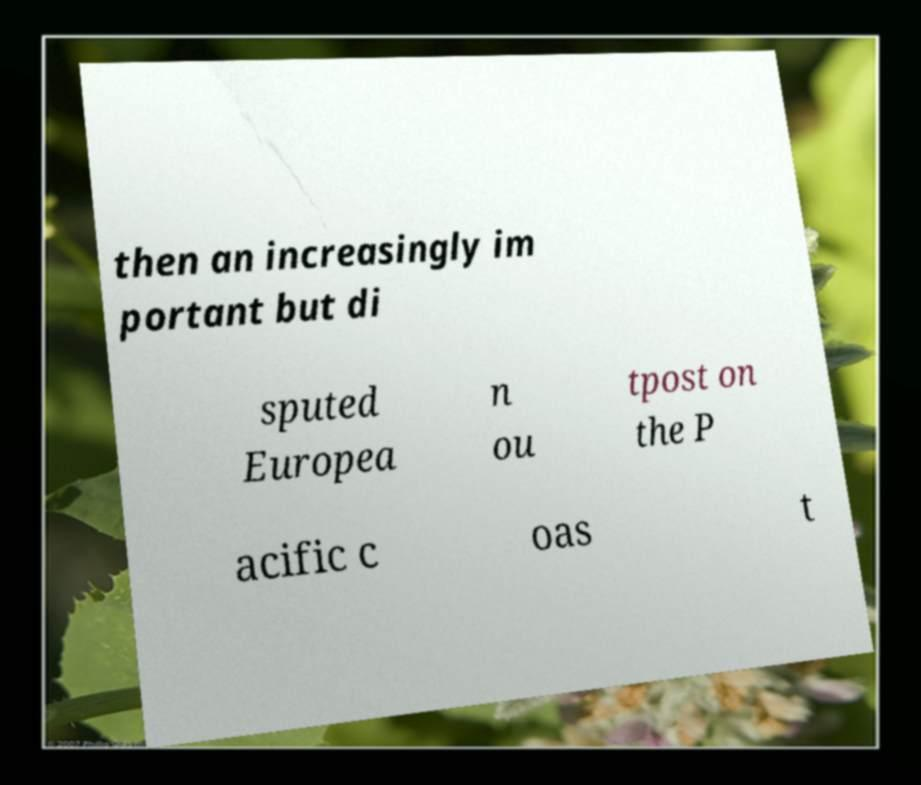Can you accurately transcribe the text from the provided image for me? then an increasingly im portant but di sputed Europea n ou tpost on the P acific c oas t 